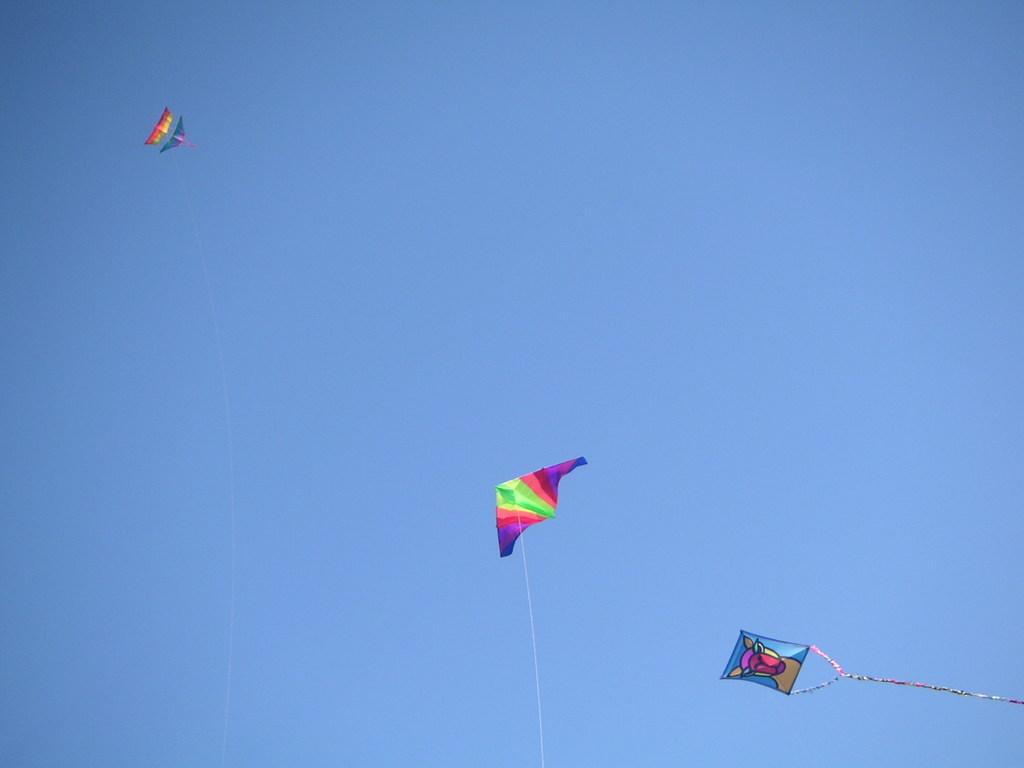What objects are in the image? There are kites in the image. What are the kites connected to? The kites have threads. What can be seen in the background of the image? There is sky visible in the background of the image. How many pigs are flying in the image? There are no pigs present in the image. 